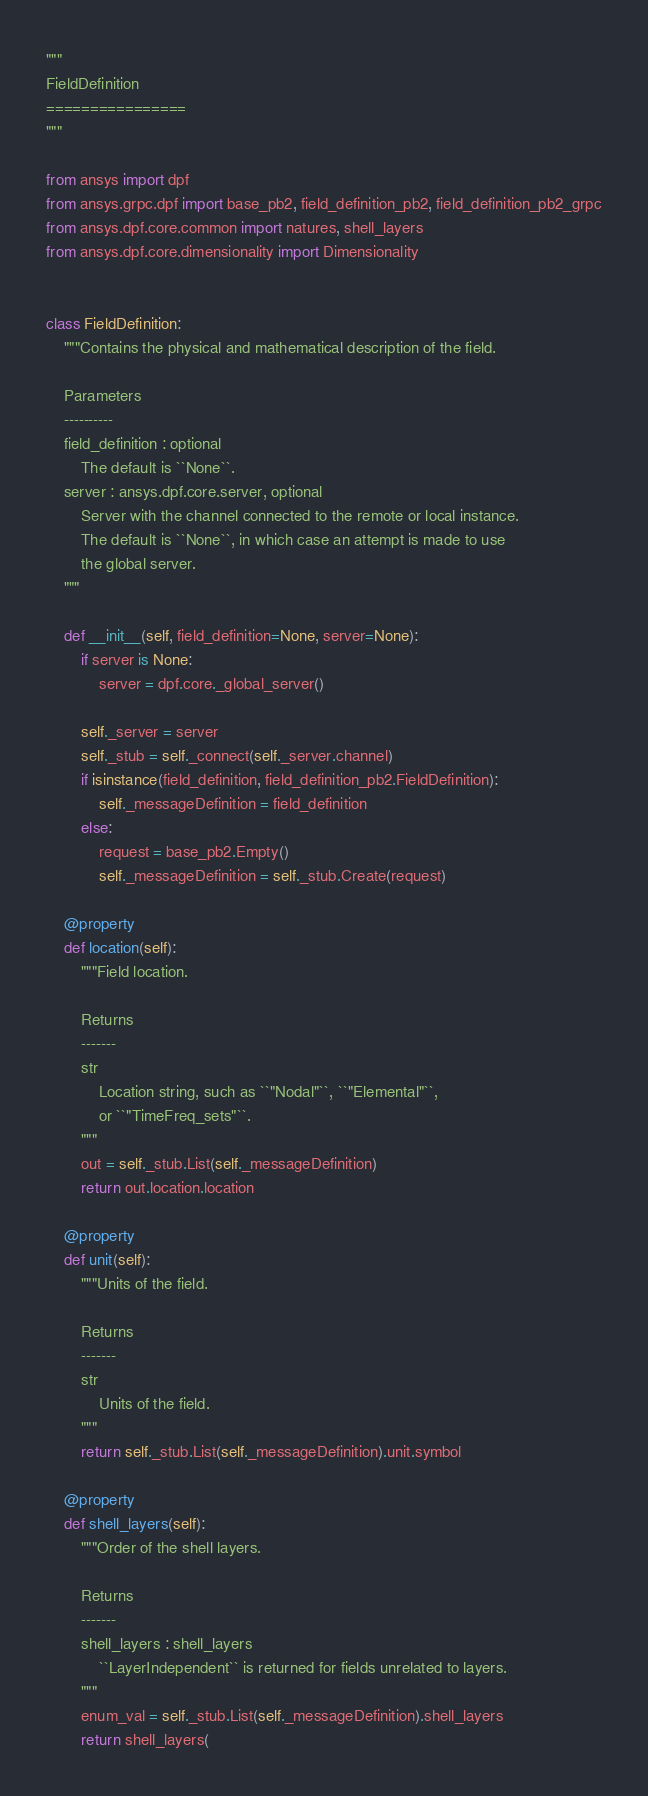<code> <loc_0><loc_0><loc_500><loc_500><_Python_>"""
FieldDefinition
================
"""

from ansys import dpf
from ansys.grpc.dpf import base_pb2, field_definition_pb2, field_definition_pb2_grpc
from ansys.dpf.core.common import natures, shell_layers
from ansys.dpf.core.dimensionality import Dimensionality


class FieldDefinition:
    """Contains the physical and mathematical description of the field.

    Parameters
    ----------
    field_definition : optional
        The default is ``None``.
    server : ansys.dpf.core.server, optional
        Server with the channel connected to the remote or local instance.
        The default is ``None``, in which case an attempt is made to use
        the global server.
    """

    def __init__(self, field_definition=None, server=None):
        if server is None:
            server = dpf.core._global_server()

        self._server = server
        self._stub = self._connect(self._server.channel)
        if isinstance(field_definition, field_definition_pb2.FieldDefinition):
            self._messageDefinition = field_definition
        else:
            request = base_pb2.Empty()
            self._messageDefinition = self._stub.Create(request)

    @property
    def location(self):
        """Field location.

        Returns
        -------
        str
            Location string, such as ``"Nodal"``, ``"Elemental"``,
            or ``"TimeFreq_sets"``.
        """
        out = self._stub.List(self._messageDefinition)
        return out.location.location

    @property
    def unit(self):
        """Units of the field.

        Returns
        -------
        str
            Units of the field.
        """
        return self._stub.List(self._messageDefinition).unit.symbol

    @property
    def shell_layers(self):
        """Order of the shell layers.

        Returns
        -------
        shell_layers : shell_layers
            ``LayerIndependent`` is returned for fields unrelated to layers.
        """
        enum_val = self._stub.List(self._messageDefinition).shell_layers
        return shell_layers(</code> 